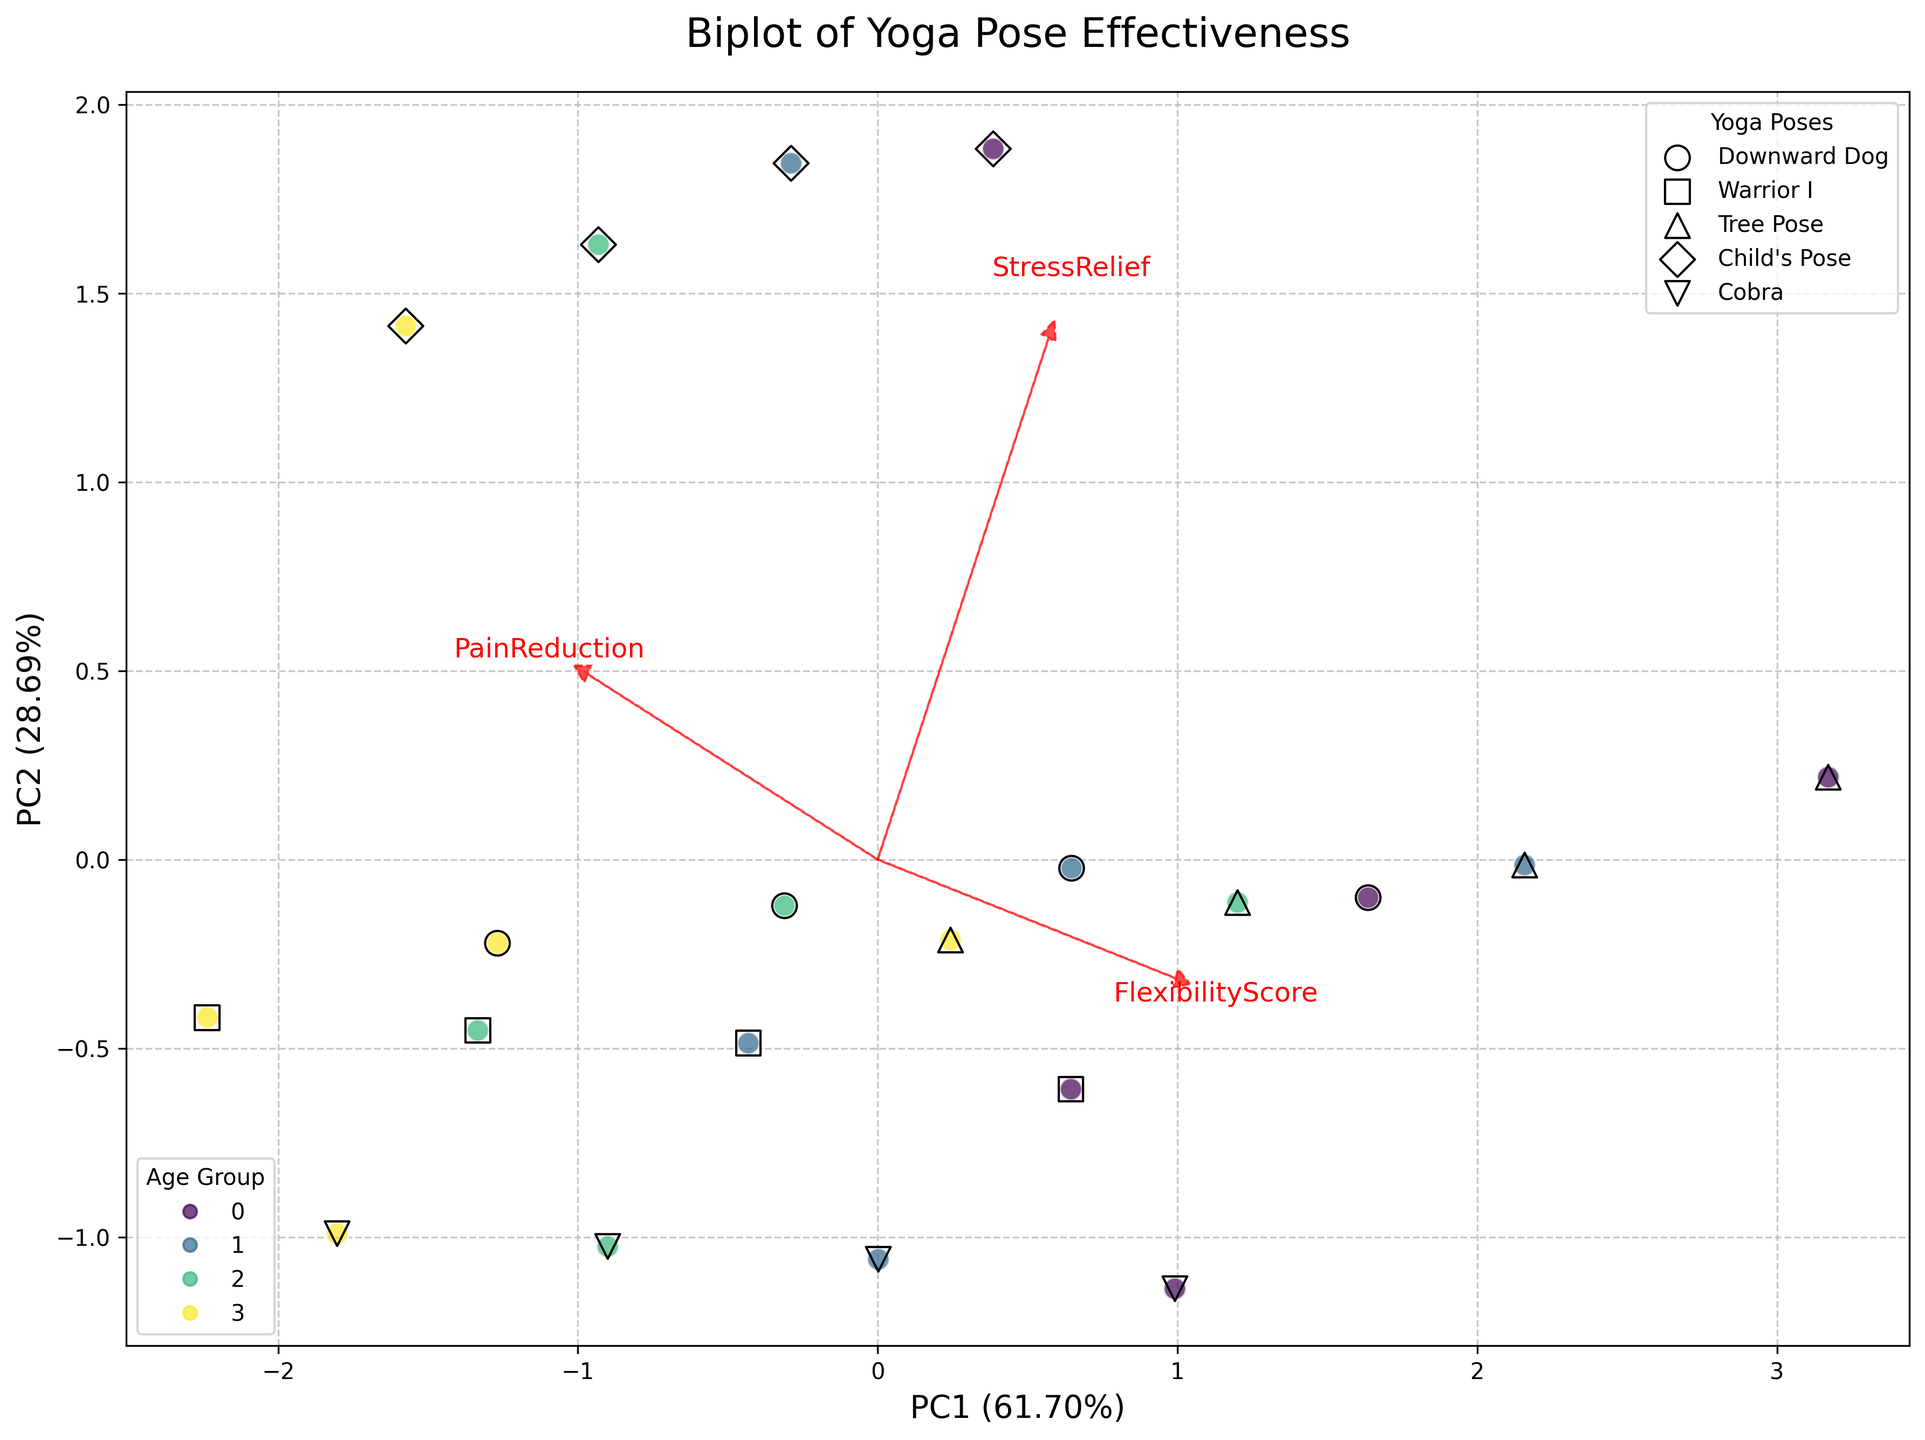What does the title of the biplot say? The title is usually prominently displayed at the top of the biplot. It can be read directly off the figure.
Answer: "Biplot of Yoga Pose Effectiveness" What are the labels of the x and y axes? The x-axis and y-axis labels usually indicate the principal components (PC1 and PC2) and their explained variance. These labels can be read directly from the plot.
Answer: PC1 and PC2 How are different age groups represented in the biplot? Age groups can be represented by different colors in the biplot. The legend in the bottom left indicates which color corresponds to which age group.
Answer: Different colors What are the red arrows in the plot, and what do they represent? Red arrows in a biplot usually represent the original features in the principal component space. They indicate the direction and contribution of each feature (FlexibilityScore, PainReduction, StressRelief).
Answer: Original features Which yoga pose appears to contribute most to Stress Relief across all age groups? Look for the red arrow labeled "StressRelief" and observe which yoga pose data points are aligned most closely with the direction of this arrow, suggesting a higher contribution.
Answer: Child's Pose Which pose has the highest FlexibilityScore for participants in the 18-30 age group? Filter out the data points for the 18-30 age group and identify the pose that falls under the highest point along the axis corresponding to "FlexibilityScore".
Answer: Tree Pose What is the range of the explained variance by the first principal component (PC1)? Locate the x-axis label, which states the explained variance. The range indicates how much variance in the data is captured by PC1.
Answer: Approximately 50% Do participants aged 46-60 show better PainReduction or StressRelief from yoga? Examine the scatter plot points for the 46-60 age group color and compare their alignment relative to the red arrows for "PainReduction" and "StressRelief".
Answer: Stress Relief Which age group shows the highest variance in the effectiveness of Warrior I pose? Analyze the spread of the data points corresponding to the Warrior I pose. Use the colors representing different age groups to determine which has the widest distribution.
Answer: 46-60 Which yoga poses appear to be more effective for increasing flexibility in older adults (60+)? Examine the data points for the 60+ age group color and see which yoga poses cluster more closely with the "FlexibilityScore" arrow direction.
Answer: Tree Pose 